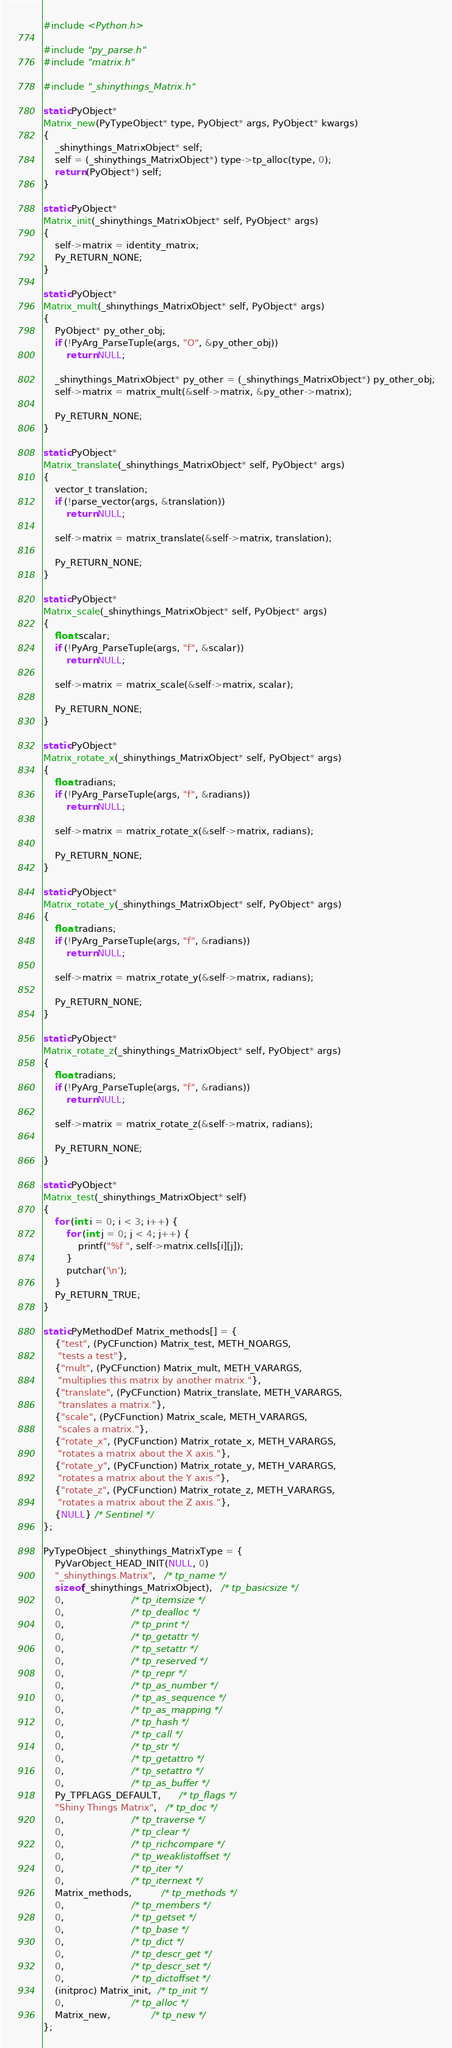<code> <loc_0><loc_0><loc_500><loc_500><_C_>#include <Python.h>

#include "py_parse.h"
#include "matrix.h"

#include "_shinythings_Matrix.h"

static PyObject*
Matrix_new(PyTypeObject* type, PyObject* args, PyObject* kwargs)
{
    _shinythings_MatrixObject* self;
    self = (_shinythings_MatrixObject*) type->tp_alloc(type, 0);
    return (PyObject*) self;
}

static PyObject*
Matrix_init(_shinythings_MatrixObject* self, PyObject* args)
{
    self->matrix = identity_matrix;
    Py_RETURN_NONE;
}

static PyObject*
Matrix_mult(_shinythings_MatrixObject* self, PyObject* args)
{
    PyObject* py_other_obj;
    if (!PyArg_ParseTuple(args, "O", &py_other_obj))
        return NULL;

    _shinythings_MatrixObject* py_other = (_shinythings_MatrixObject*) py_other_obj;
    self->matrix = matrix_mult(&self->matrix, &py_other->matrix);

    Py_RETURN_NONE;
}

static PyObject*
Matrix_translate(_shinythings_MatrixObject* self, PyObject* args)
{
    vector_t translation;
    if (!parse_vector(args, &translation))
        return NULL;

    self->matrix = matrix_translate(&self->matrix, translation);

    Py_RETURN_NONE;
}

static PyObject*
Matrix_scale(_shinythings_MatrixObject* self, PyObject* args)
{
    float scalar;
    if (!PyArg_ParseTuple(args, "f", &scalar))
        return NULL;

    self->matrix = matrix_scale(&self->matrix, scalar);

    Py_RETURN_NONE;
}

static PyObject*
Matrix_rotate_x(_shinythings_MatrixObject* self, PyObject* args)
{
    float radians;
    if (!PyArg_ParseTuple(args, "f", &radians))
        return NULL;

    self->matrix = matrix_rotate_x(&self->matrix, radians);

    Py_RETURN_NONE;
}

static PyObject*
Matrix_rotate_y(_shinythings_MatrixObject* self, PyObject* args)
{
    float radians;
    if (!PyArg_ParseTuple(args, "f", &radians))
        return NULL;

    self->matrix = matrix_rotate_y(&self->matrix, radians);

    Py_RETURN_NONE;
}

static PyObject*
Matrix_rotate_z(_shinythings_MatrixObject* self, PyObject* args)
{
    float radians;
    if (!PyArg_ParseTuple(args, "f", &radians))
        return NULL;

    self->matrix = matrix_rotate_z(&self->matrix, radians);

    Py_RETURN_NONE;
}

static PyObject*
Matrix_test(_shinythings_MatrixObject* self)
{
    for (int i = 0; i < 3; i++) {
        for (int j = 0; j < 4; j++) {
            printf("%f ", self->matrix.cells[i][j]);
        }
        putchar('\n');
    }
    Py_RETURN_TRUE;
}

static PyMethodDef Matrix_methods[] = {
    {"test", (PyCFunction) Matrix_test, METH_NOARGS,
     "tests a test"},
    {"mult", (PyCFunction) Matrix_mult, METH_VARARGS,
     "multiplies this matrix by another matrix."},
    {"translate", (PyCFunction) Matrix_translate, METH_VARARGS,
     "translates a matrix."},
    {"scale", (PyCFunction) Matrix_scale, METH_VARARGS,
     "scales a matrix."},
    {"rotate_x", (PyCFunction) Matrix_rotate_x, METH_VARARGS,
     "rotates a matrix about the X axis."},
    {"rotate_y", (PyCFunction) Matrix_rotate_y, METH_VARARGS,
     "rotates a matrix about the Y axis."},
    {"rotate_z", (PyCFunction) Matrix_rotate_z, METH_VARARGS,
     "rotates a matrix about the Z axis."},
    {NULL} /* Sentinel */
};

PyTypeObject _shinythings_MatrixType = {
    PyVarObject_HEAD_INIT(NULL, 0)
    "_shinythings.Matrix",   /* tp_name */
    sizeof(_shinythings_MatrixObject),   /* tp_basicsize */
    0,                       /* tp_itemsize */
    0,                       /* tp_dealloc */
    0,                       /* tp_print */
    0,                       /* tp_getattr */
    0,                       /* tp_setattr */
    0,                       /* tp_reserved */
    0,                       /* tp_repr */
    0,                       /* tp_as_number */
    0,                       /* tp_as_sequence */
    0,                       /* tp_as_mapping */
    0,                       /* tp_hash */
    0,                       /* tp_call */
    0,                       /* tp_str */
    0,                       /* tp_getattro */
    0,                       /* tp_setattro */
    0,                       /* tp_as_buffer */
    Py_TPFLAGS_DEFAULT,      /* tp_flags */
    "Shiny Things Matrix",   /* tp_doc */
    0,                       /* tp_traverse */
    0,                       /* tp_clear */
    0,                       /* tp_richcompare */
    0,                       /* tp_weaklistoffset */
    0,                       /* tp_iter */
    0,                       /* tp_iternext */
    Matrix_methods,          /* tp_methods */
    0,                       /* tp_members */
    0,                       /* tp_getset */
    0,                       /* tp_base */
    0,                       /* tp_dict */
    0,                       /* tp_descr_get */
    0,                       /* tp_descr_set */
    0,                       /* tp_dictoffset */
    (initproc) Matrix_init,  /* tp_init */
    0,                       /* tp_alloc */
    Matrix_new,              /* tp_new */
};


</code> 